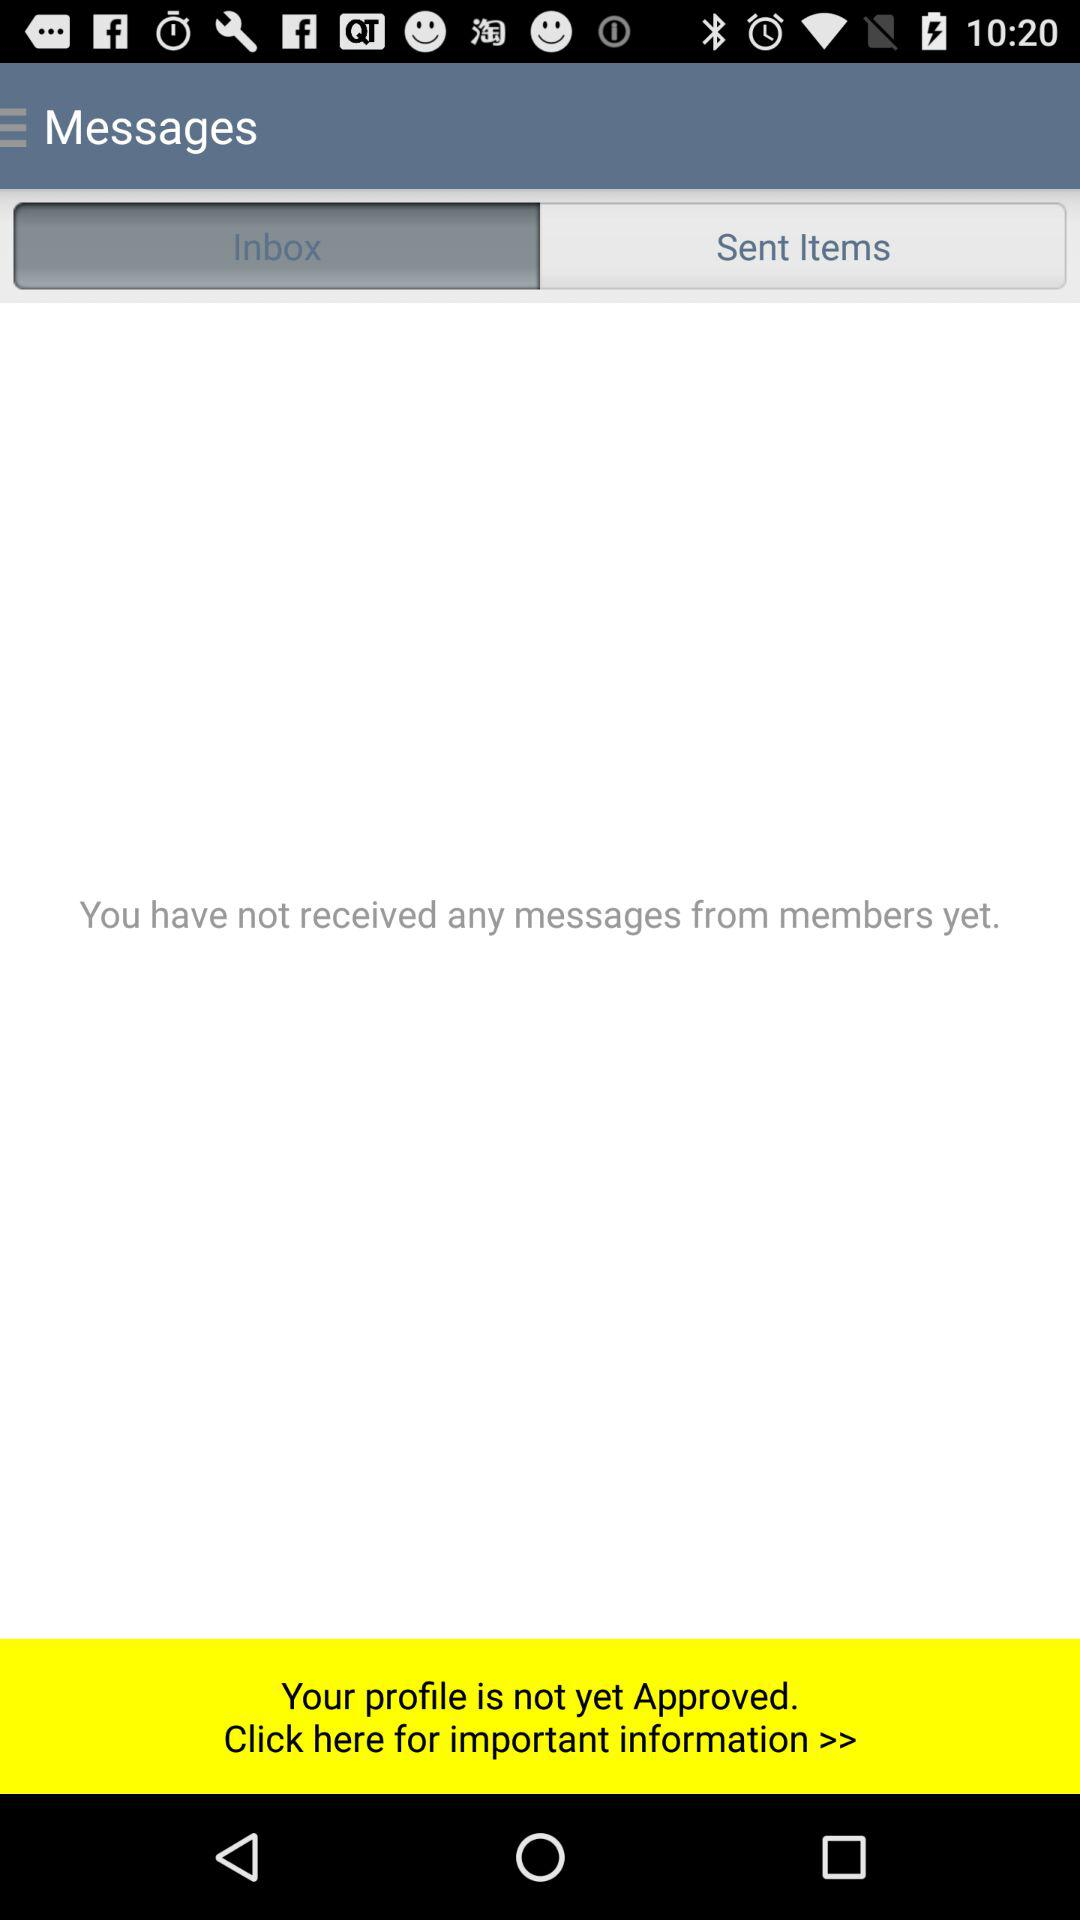Is there any received message? There is no message received. 